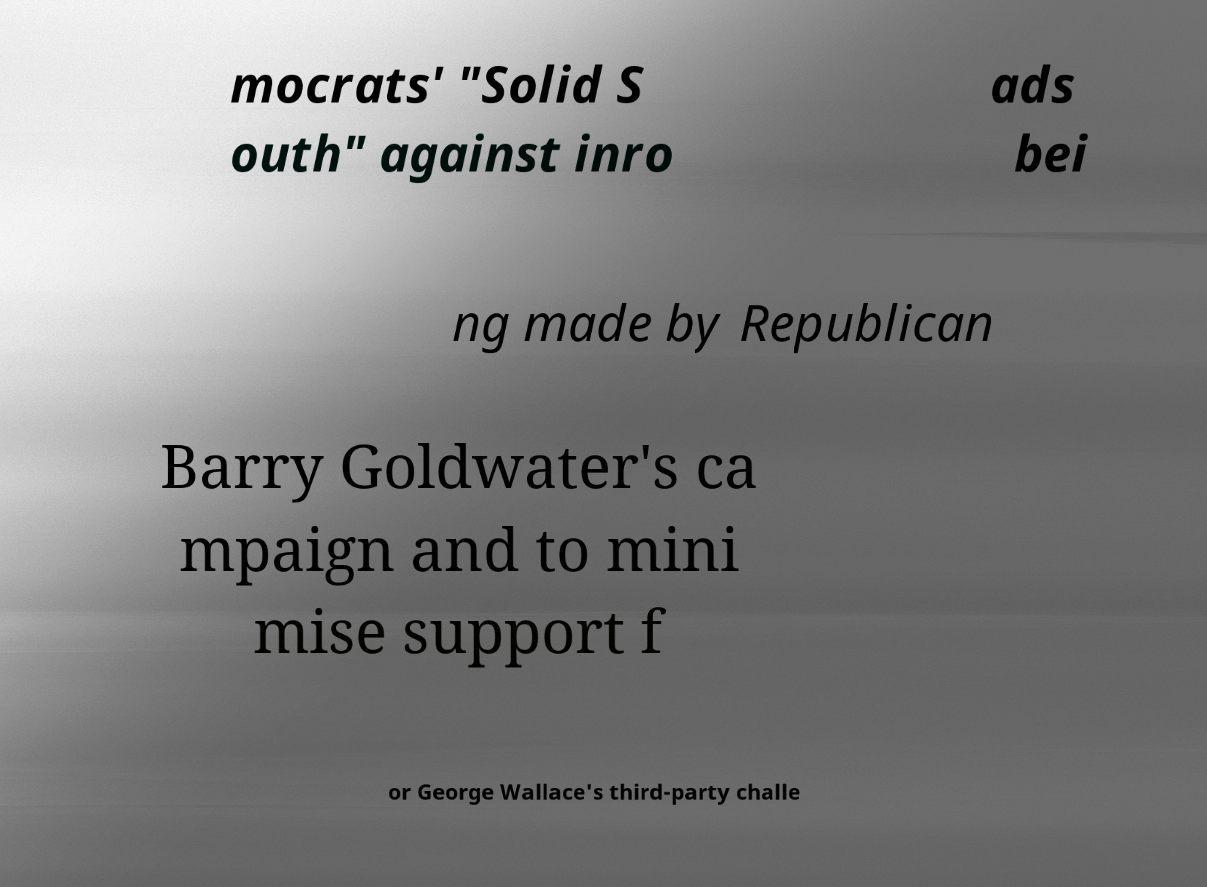For documentation purposes, I need the text within this image transcribed. Could you provide that? mocrats' "Solid S outh" against inro ads bei ng made by Republican Barry Goldwater's ca mpaign and to mini mise support f or George Wallace's third-party challe 